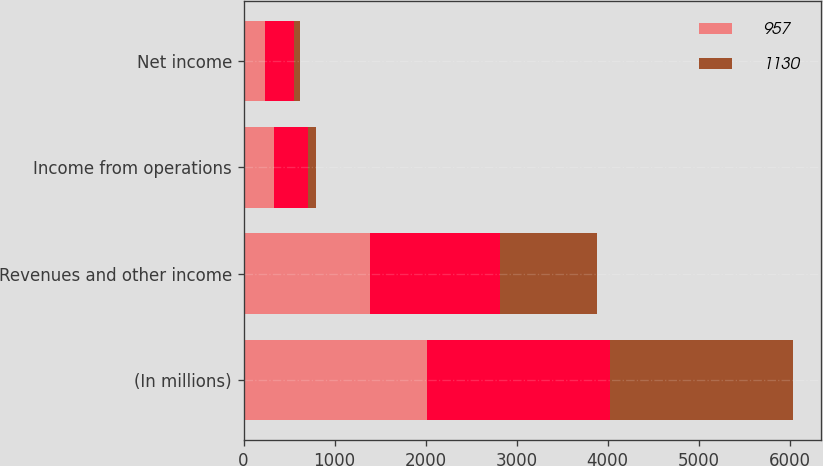<chart> <loc_0><loc_0><loc_500><loc_500><stacked_bar_chart><ecel><fcel>(In millions)<fcel>Revenues and other income<fcel>Income from operations<fcel>Net income<nl><fcel>957<fcel>2015<fcel>1390<fcel>332<fcel>239<nl><fcel>nan<fcel>2014<fcel>1430<fcel>379<fcel>316<nl><fcel>1130<fcel>2013<fcel>1067<fcel>87<fcel>63<nl></chart> 